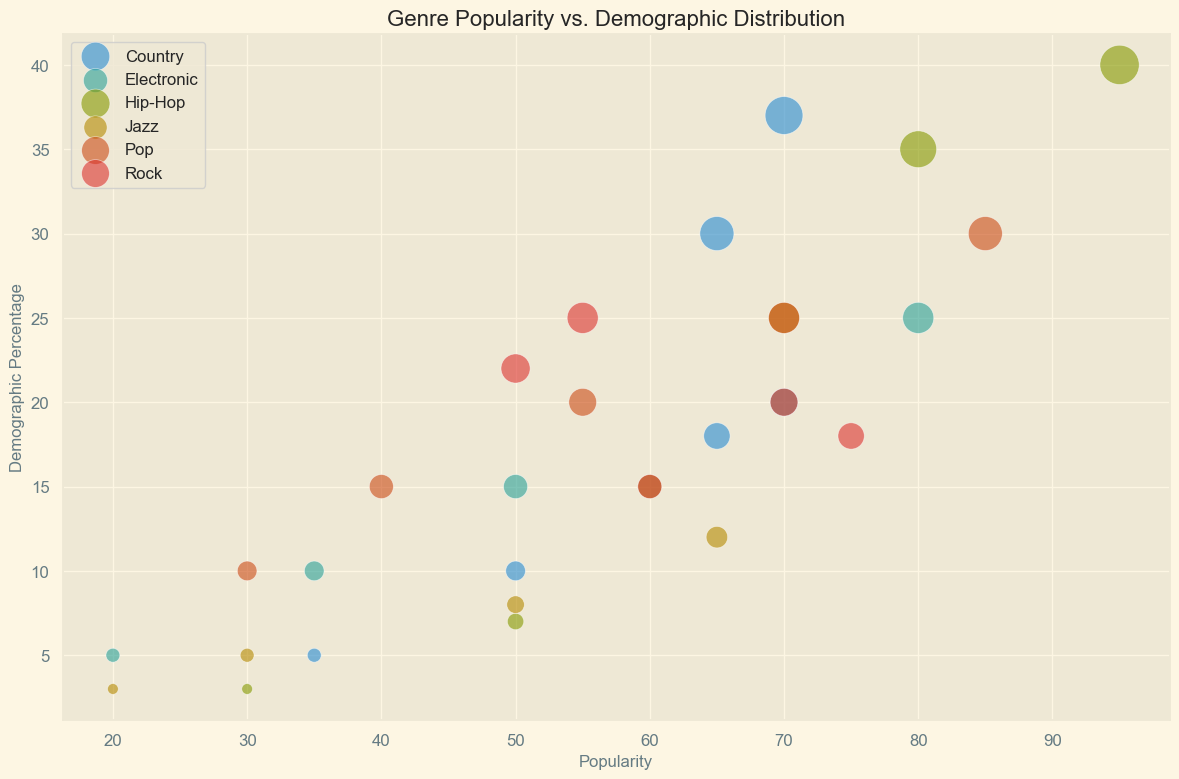Which genre has the highest popularity among the 18-24 age group? Look at the bubbles in the 18-24 age group along the x-axis for the highest value. The 18-24 age group has the highest popularity for Hip-Hop at a value of 95.
Answer: Hip-Hop Which age group shows the highest demographic percentage for Country music? Look for the largest bubble in the Country category, as the size of the bubble represents the demographic percentage. The largest bubble is in the 55+ age group with a demographic percentage of 37.
Answer: 55+ Which genre-target age combination has the lowest popularity? Look for the smallest values along the x-axis across all genres and age groups. The Jazz genre for the 18-24 age group has the smallest popularity at 20.
Answer: Jazz, 18-24 Among people aged 25-34, which genre has the highest popularity? Compare the bubbles along the 25-34 age group for their x-axis values to find the highest. The Hip-Hop genre has the highest popularity at 80.
Answer: Hip-Hop Which genre has more balanced popularity across different age groups, Rock or Jazz? Observe the spread of the popularity (x-axis values) for both Rock and Jazz across age groups. Rock appears to have a more consistent spread in the popularity values compared to Jazz.
Answer: Rock What is the average popularity of the Pop genre across all age groups? Sum the popularity values for Pop (85 + 70 + 55 + 40 + 30) and divide by the number of values (5). The average is (85+70+55+40+30)/5 = 280/5 = 56.
Answer: 56 Does the popularity of Hip-Hop decrease more steeply with age compared to Country? Compare the slope or drop in popularity values as age increases for both genres. Hip-Hop's popularity decreases from 95 to 30, while Country shows an increase from 35 to 70. Hip-Hop does show a steeper decrease with age.
Answer: Yes Which genre has the largest demographic bubble in the 35-44 age group? Look at the bubbles in the 35-44 age group along the y-axis for size. Country has the largest demographic bubble at 18%.
Answer: Country Which genre has the highest popularity for the age group with the smallest percentage of their demographic? Identify the age group with the smallest demographic percentage across all genres, which is Hip-Hop for the 55+ age group at 3%. Hip-Hop has a popularity of 30 in this age group.
Answer: Hip-Hop 